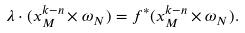<formula> <loc_0><loc_0><loc_500><loc_500>\lambda \cdot ( x _ { M } ^ { k - n } \times \omega _ { N } ) = f ^ { * } ( x _ { M } ^ { k - n } \times \omega _ { N } ) .</formula> 